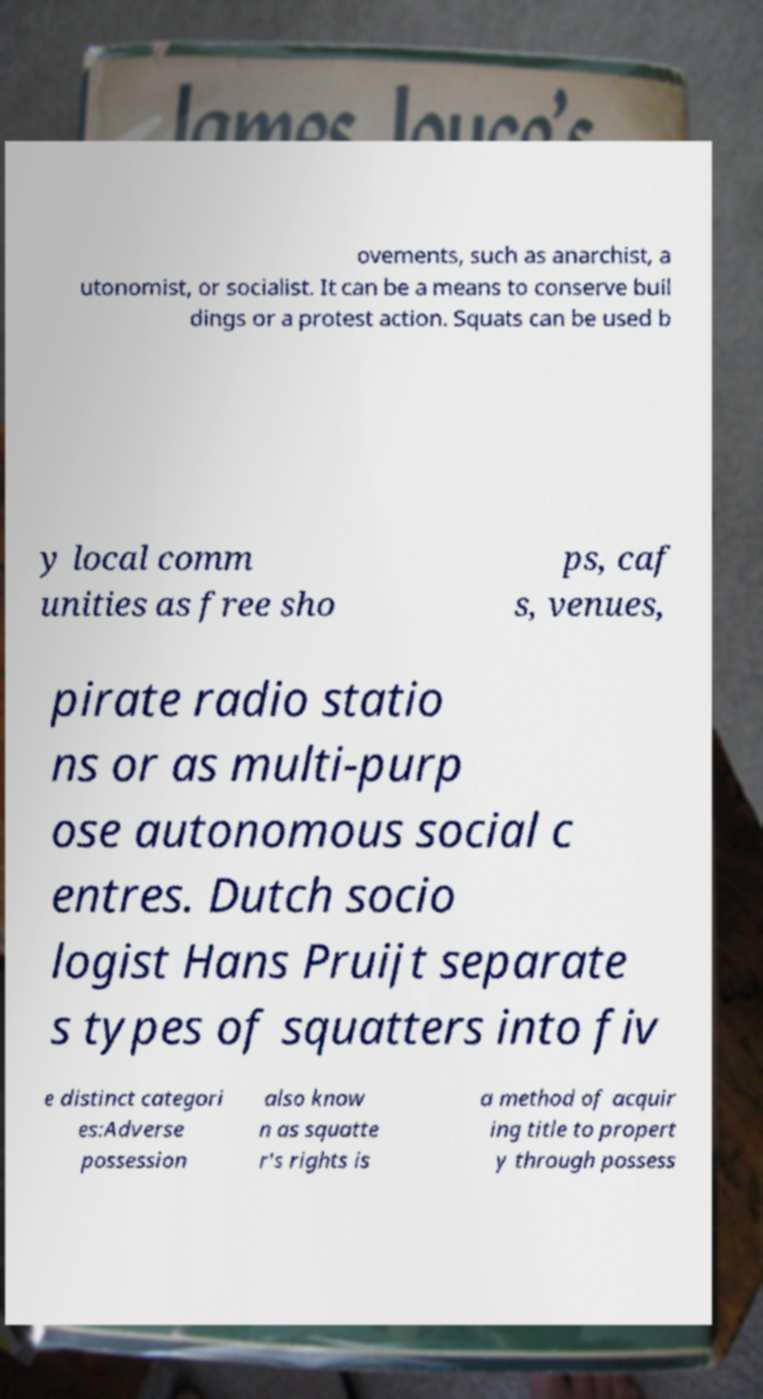Please read and relay the text visible in this image. What does it say? ovements, such as anarchist, a utonomist, or socialist. It can be a means to conserve buil dings or a protest action. Squats can be used b y local comm unities as free sho ps, caf s, venues, pirate radio statio ns or as multi-purp ose autonomous social c entres. Dutch socio logist Hans Pruijt separate s types of squatters into fiv e distinct categori es:Adverse possession also know n as squatte r's rights is a method of acquir ing title to propert y through possess 